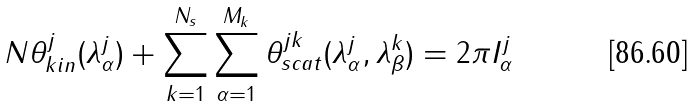Convert formula to latex. <formula><loc_0><loc_0><loc_500><loc_500>N \theta ^ { j } _ { k i n } ( \lambda ^ { j } _ { \alpha } ) + \sum _ { k = 1 } ^ { N _ { s } } \sum _ { \alpha = 1 } ^ { M _ { k } } \theta ^ { j k } _ { s c a t } ( \lambda ^ { j } _ { \alpha } , \lambda ^ { k } _ { \beta } ) = 2 \pi I ^ { j } _ { \alpha }</formula> 